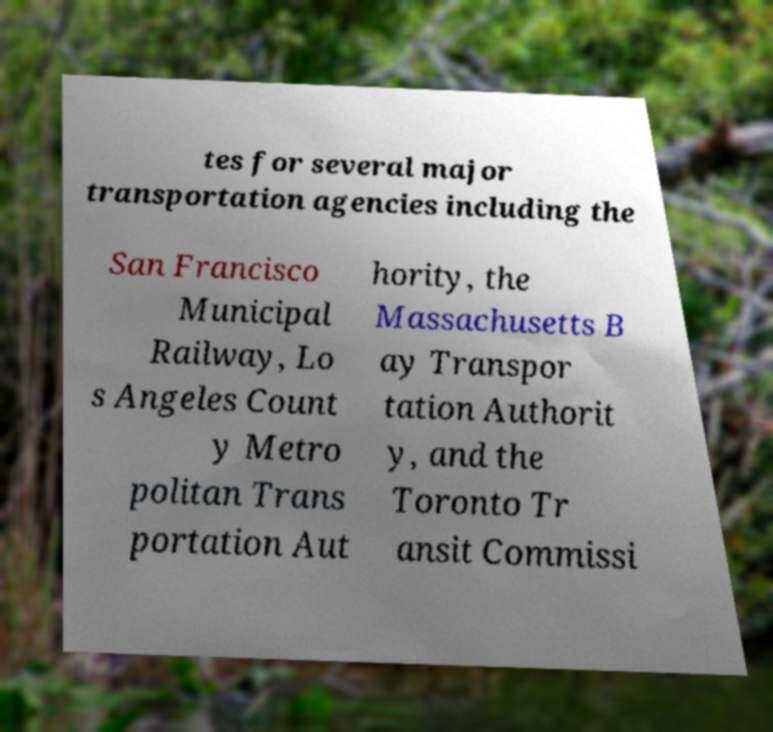Please read and relay the text visible in this image. What does it say? tes for several major transportation agencies including the San Francisco Municipal Railway, Lo s Angeles Count y Metro politan Trans portation Aut hority, the Massachusetts B ay Transpor tation Authorit y, and the Toronto Tr ansit Commissi 